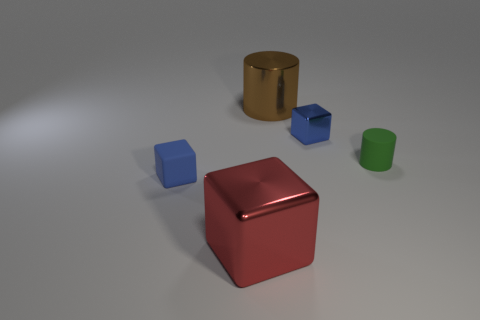Add 5 brown objects. How many objects exist? 10 Subtract all tiny blue matte cubes. How many cubes are left? 2 Subtract all red blocks. How many blocks are left? 2 Subtract all purple cylinders. Subtract all yellow cubes. How many cylinders are left? 2 Subtract all red blocks. How many red cylinders are left? 0 Subtract all small rubber blocks. Subtract all blue cylinders. How many objects are left? 4 Add 3 big metallic cylinders. How many big metallic cylinders are left? 4 Add 4 tiny yellow cylinders. How many tiny yellow cylinders exist? 4 Subtract 0 yellow blocks. How many objects are left? 5 Subtract all blocks. How many objects are left? 2 